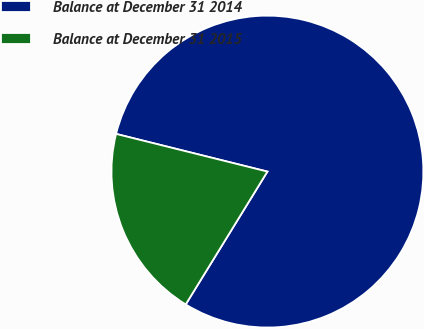<chart> <loc_0><loc_0><loc_500><loc_500><pie_chart><fcel>Balance at December 31 2014<fcel>Balance at December 31 2015<nl><fcel>79.89%<fcel>20.11%<nl></chart> 